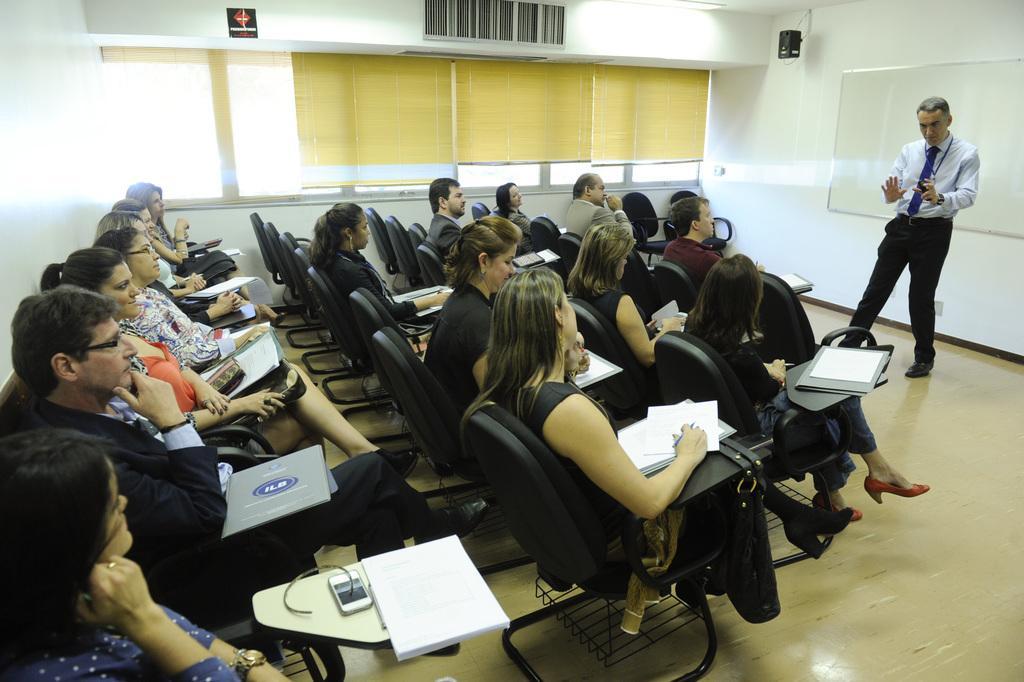Please provide a concise description of this image. This is an inside view of a room. In the middle of the image few people are sitting on the chairs facing towards the right side. They are holding few papers in their hands and looking at the man who is standing on the right side and speaking. At the back of this man there is a board attached to the wall. In the background there are few windows. 